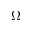Convert formula to latex. <formula><loc_0><loc_0><loc_500><loc_500>\Omega</formula> 